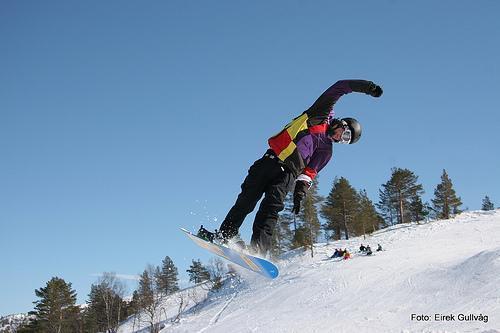How many people are in the photo?
Give a very brief answer. 1. 